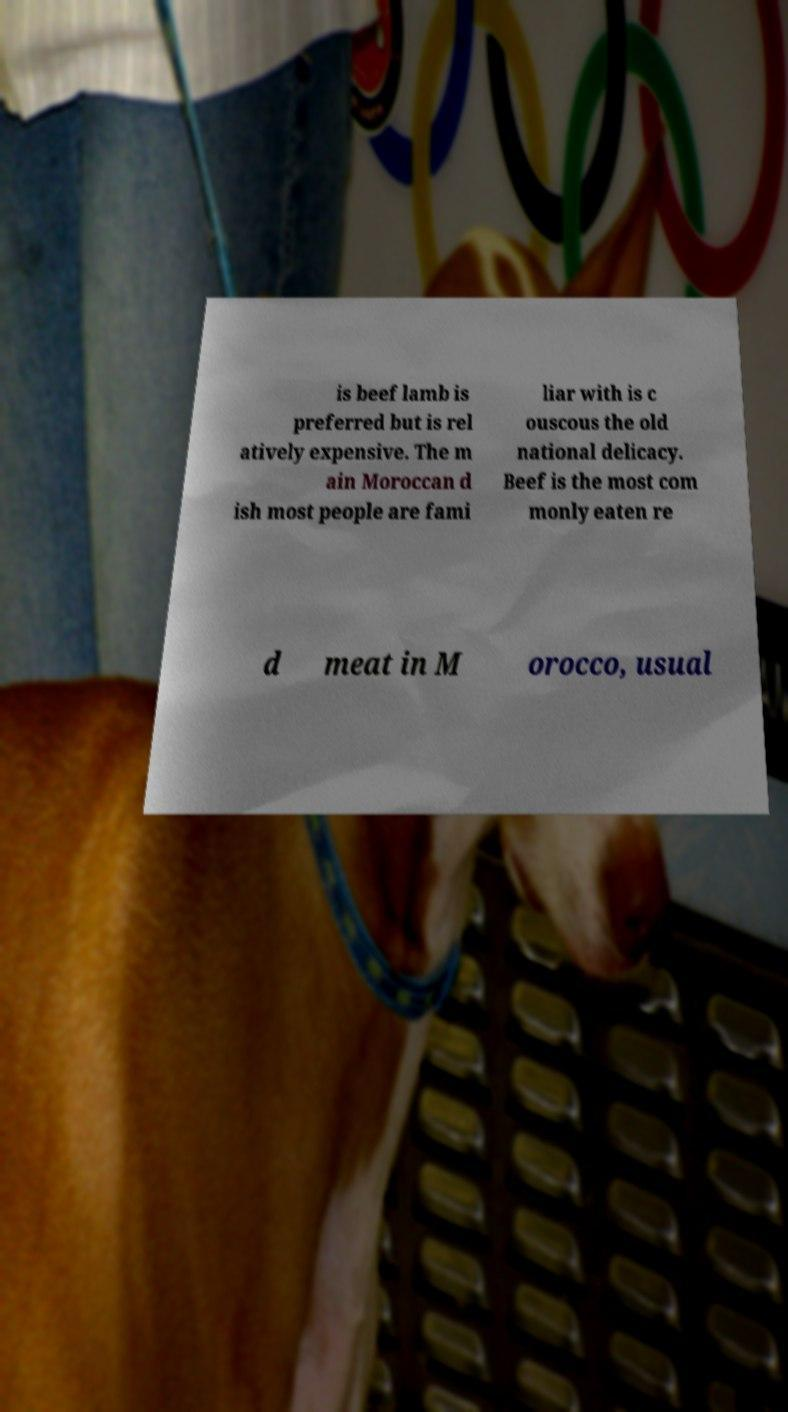For documentation purposes, I need the text within this image transcribed. Could you provide that? is beef lamb is preferred but is rel atively expensive. The m ain Moroccan d ish most people are fami liar with is c ouscous the old national delicacy. Beef is the most com monly eaten re d meat in M orocco, usual 